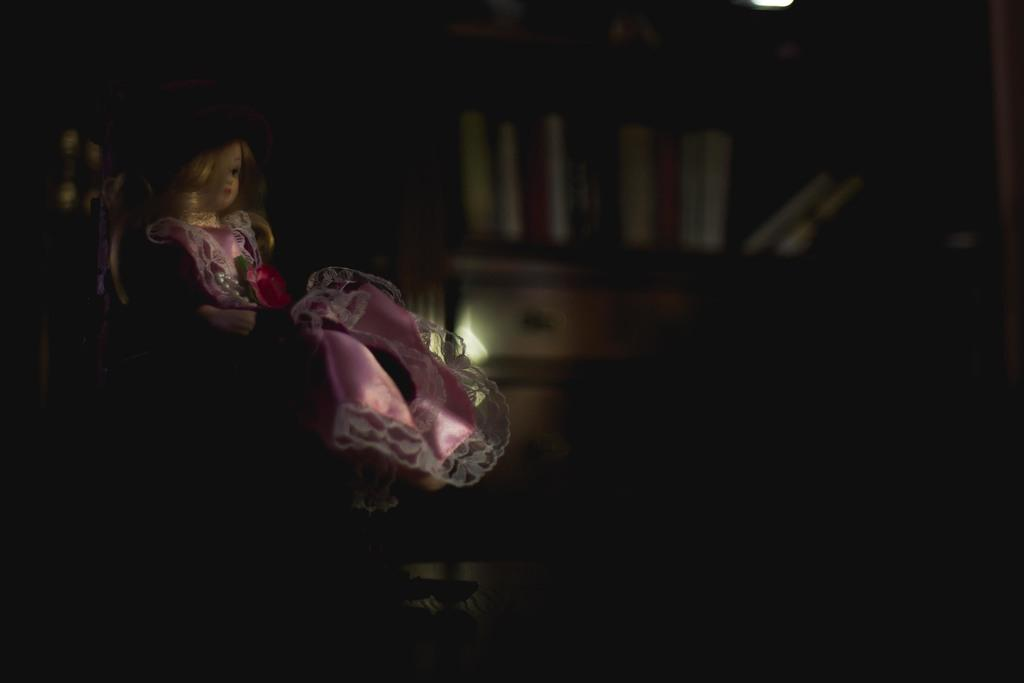What is the main subject of the image? There is a doll in the image. What is the doll doing in the image? The doll is sitting on a chair. Can you describe the background of the image? The background of the image is dark. What type of reaction can be seen from the pigs in the image? There are no pigs present in the image, so it is not possible to determine their reaction. 